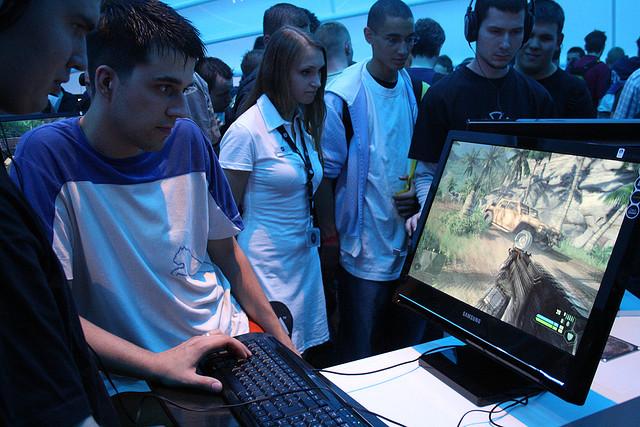Where are the earphones?
Short answer required. On man's ears. Are these people at the hospital?
Write a very short answer. No. What genre game are they playing?
Answer briefly. Shooter. 